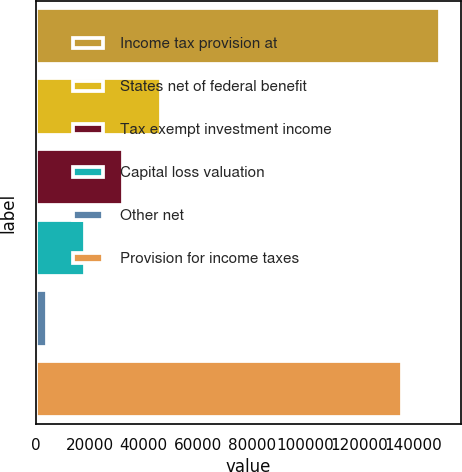Convert chart. <chart><loc_0><loc_0><loc_500><loc_500><bar_chart><fcel>Income tax provision at<fcel>States net of federal benefit<fcel>Tax exempt investment income<fcel>Capital loss valuation<fcel>Other net<fcel>Provision for income taxes<nl><fcel>149977<fcel>46574<fcel>32435<fcel>18296<fcel>4157<fcel>135838<nl></chart> 